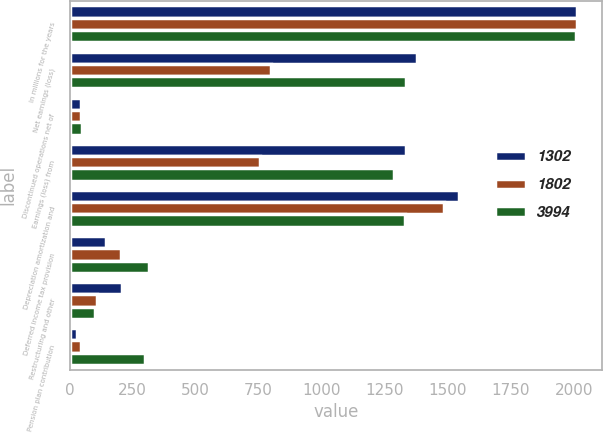Convert chart to OTSL. <chart><loc_0><loc_0><loc_500><loc_500><stacked_bar_chart><ecel><fcel>In millions for the years<fcel>Net earnings (loss)<fcel>Discontinued operations net of<fcel>Earnings (loss) from<fcel>Depreciation amortization and<fcel>Deferred income tax provision<fcel>Restructuring and other<fcel>Pension plan contribution<nl><fcel>1302<fcel>2013<fcel>1378<fcel>45<fcel>1333<fcel>1547<fcel>146<fcel>210<fcel>31<nl><fcel>1802<fcel>2012<fcel>799<fcel>45<fcel>754<fcel>1486<fcel>204<fcel>109<fcel>44<nl><fcel>3994<fcel>2011<fcel>1336<fcel>49<fcel>1287<fcel>1332<fcel>317<fcel>102<fcel>300<nl></chart> 